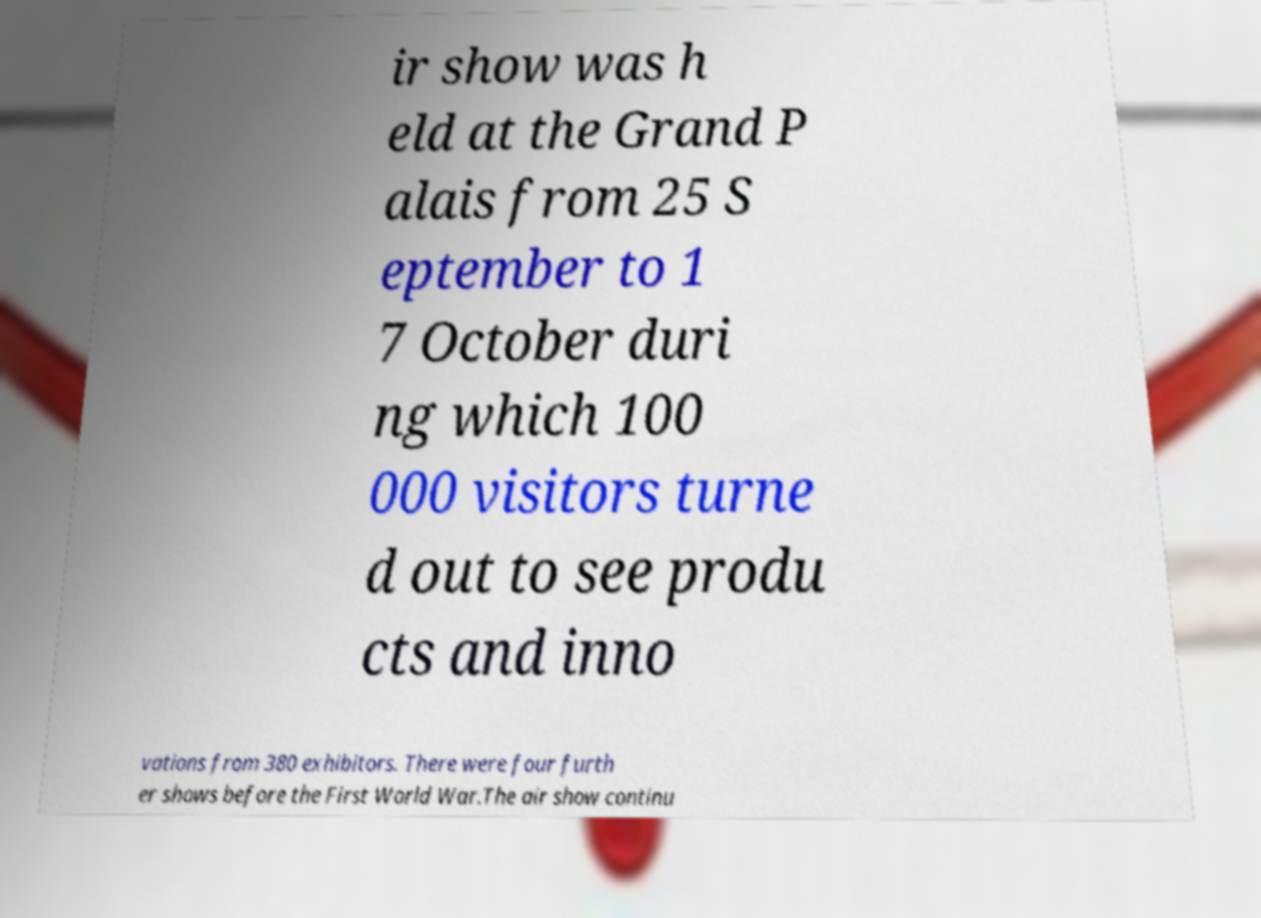Can you read and provide the text displayed in the image?This photo seems to have some interesting text. Can you extract and type it out for me? ir show was h eld at the Grand P alais from 25 S eptember to 1 7 October duri ng which 100 000 visitors turne d out to see produ cts and inno vations from 380 exhibitors. There were four furth er shows before the First World War.The air show continu 